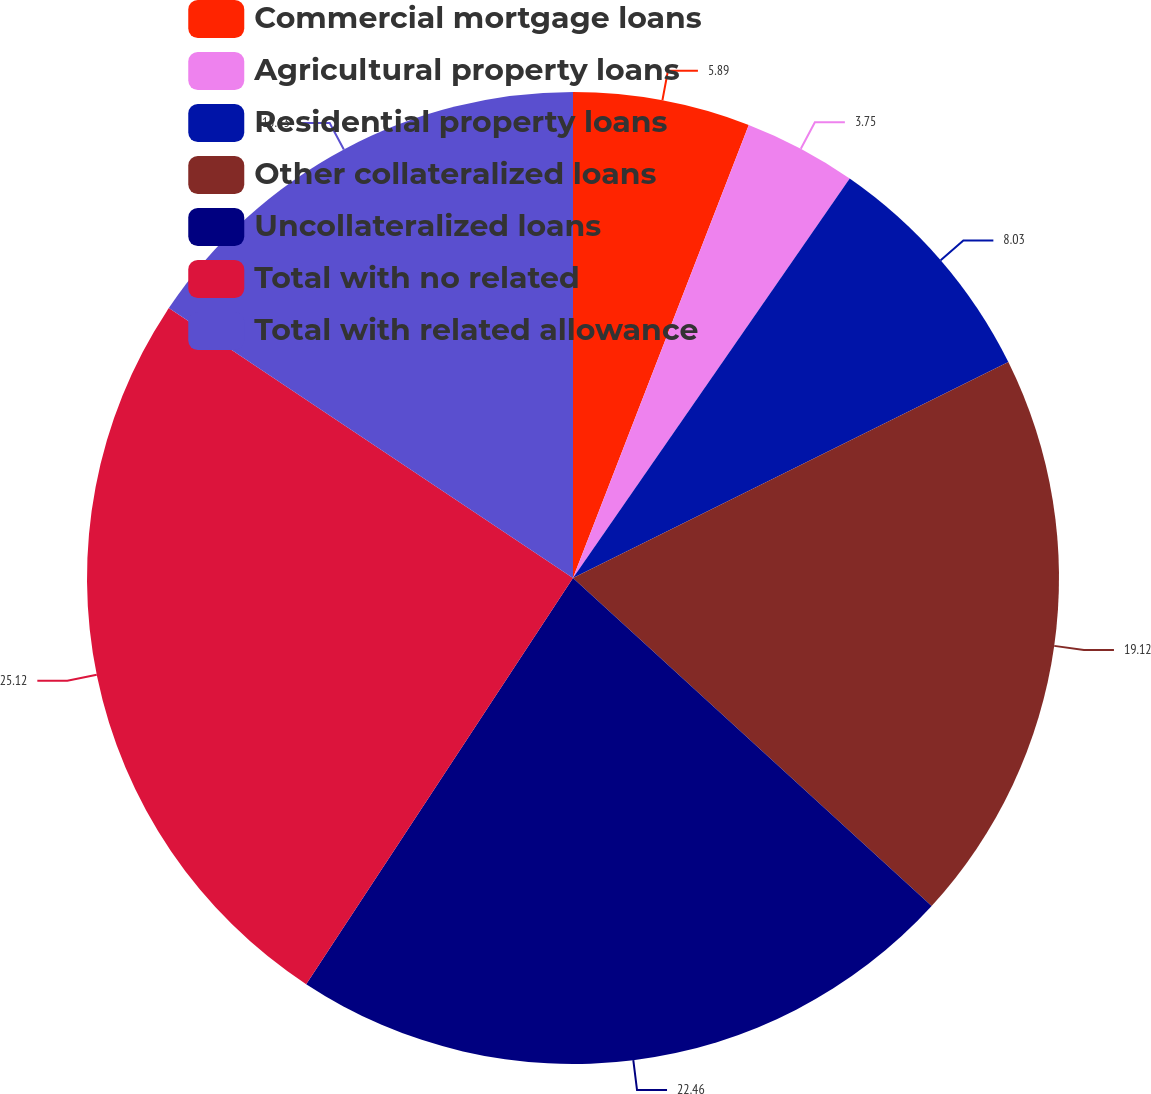<chart> <loc_0><loc_0><loc_500><loc_500><pie_chart><fcel>Commercial mortgage loans<fcel>Agricultural property loans<fcel>Residential property loans<fcel>Other collateralized loans<fcel>Uncollateralized loans<fcel>Total with no related<fcel>Total with related allowance<nl><fcel>5.89%<fcel>3.75%<fcel>8.03%<fcel>19.12%<fcel>22.46%<fcel>25.12%<fcel>15.63%<nl></chart> 